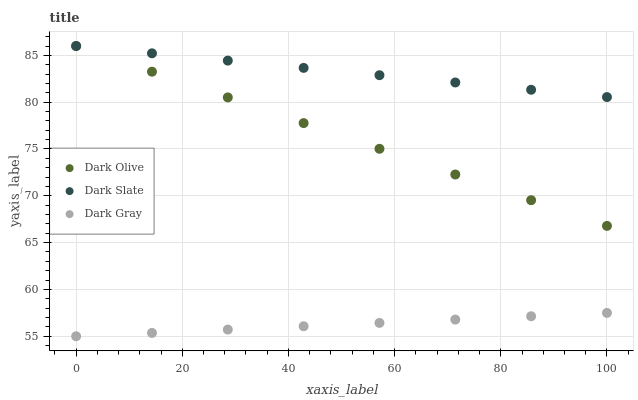Does Dark Gray have the minimum area under the curve?
Answer yes or no. Yes. Does Dark Slate have the maximum area under the curve?
Answer yes or no. Yes. Does Dark Olive have the minimum area under the curve?
Answer yes or no. No. Does Dark Olive have the maximum area under the curve?
Answer yes or no. No. Is Dark Slate the smoothest?
Answer yes or no. Yes. Is Dark Gray the roughest?
Answer yes or no. Yes. Is Dark Olive the smoothest?
Answer yes or no. No. Is Dark Olive the roughest?
Answer yes or no. No. Does Dark Gray have the lowest value?
Answer yes or no. Yes. Does Dark Olive have the lowest value?
Answer yes or no. No. Does Dark Olive have the highest value?
Answer yes or no. Yes. Is Dark Gray less than Dark Slate?
Answer yes or no. Yes. Is Dark Slate greater than Dark Gray?
Answer yes or no. Yes. Does Dark Olive intersect Dark Slate?
Answer yes or no. Yes. Is Dark Olive less than Dark Slate?
Answer yes or no. No. Is Dark Olive greater than Dark Slate?
Answer yes or no. No. Does Dark Gray intersect Dark Slate?
Answer yes or no. No. 